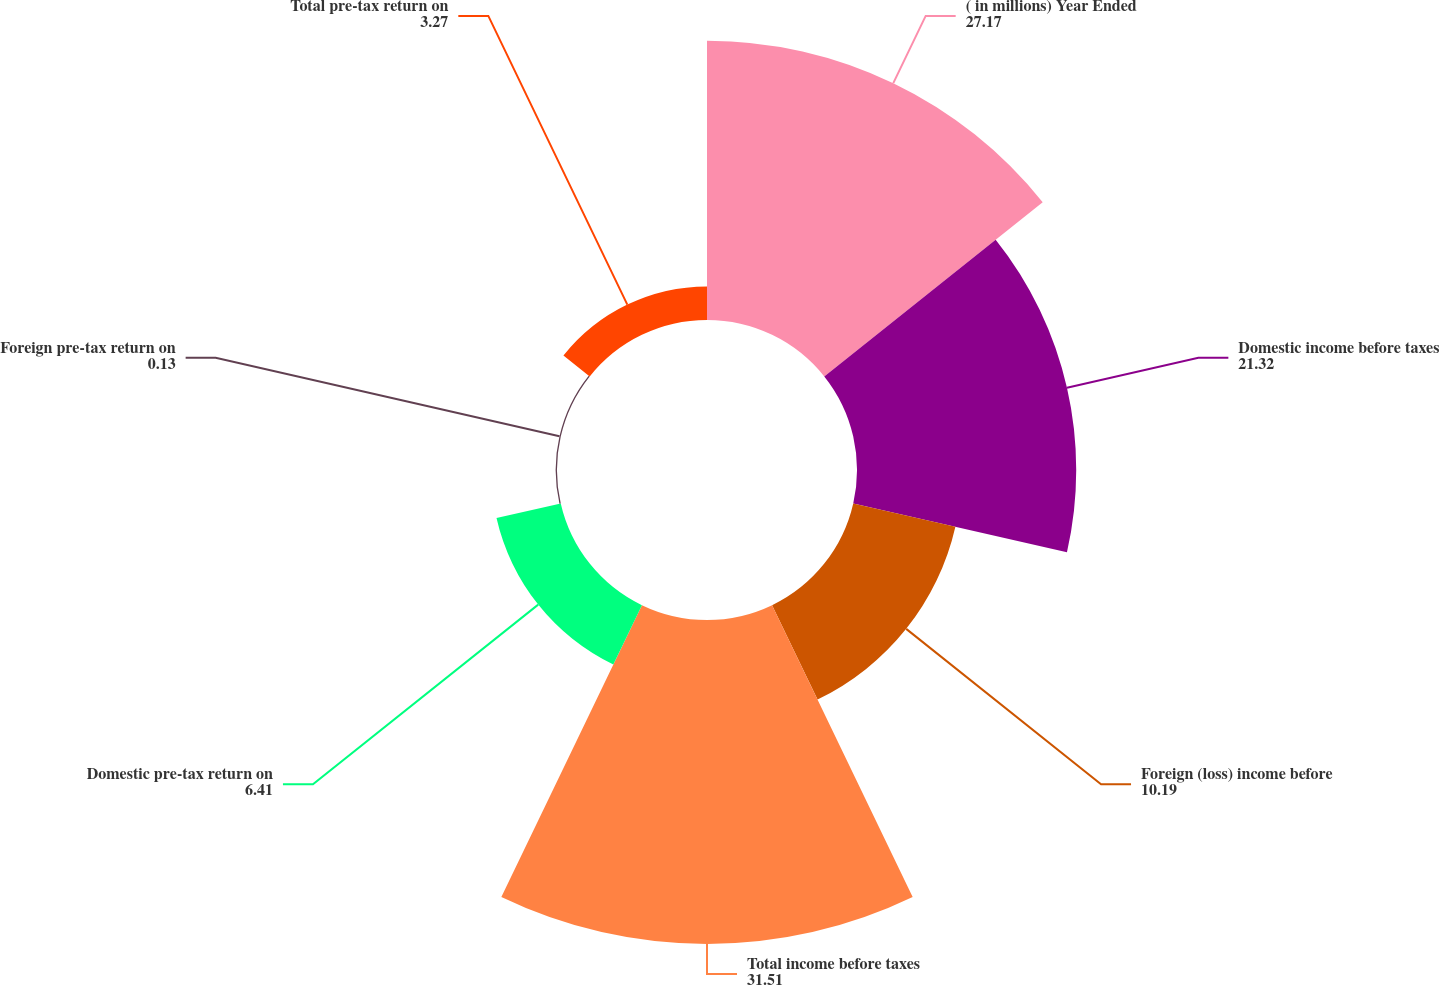Convert chart to OTSL. <chart><loc_0><loc_0><loc_500><loc_500><pie_chart><fcel>( in millions) Year Ended<fcel>Domestic income before taxes<fcel>Foreign (loss) income before<fcel>Total income before taxes<fcel>Domestic pre-tax return on<fcel>Foreign pre-tax return on<fcel>Total pre-tax return on<nl><fcel>27.17%<fcel>21.32%<fcel>10.19%<fcel>31.51%<fcel>6.41%<fcel>0.13%<fcel>3.27%<nl></chart> 